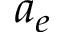Convert formula to latex. <formula><loc_0><loc_0><loc_500><loc_500>a _ { e }</formula> 